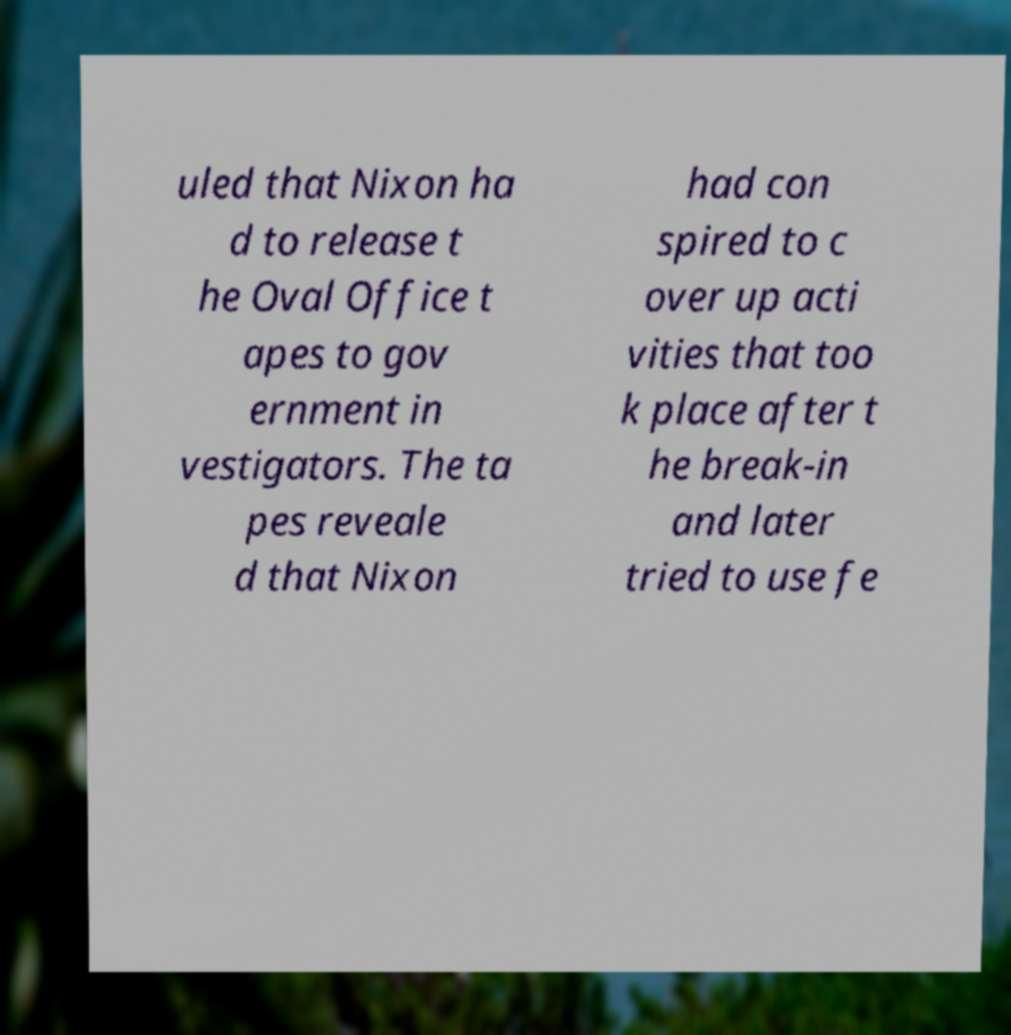Could you assist in decoding the text presented in this image and type it out clearly? uled that Nixon ha d to release t he Oval Office t apes to gov ernment in vestigators. The ta pes reveale d that Nixon had con spired to c over up acti vities that too k place after t he break-in and later tried to use fe 